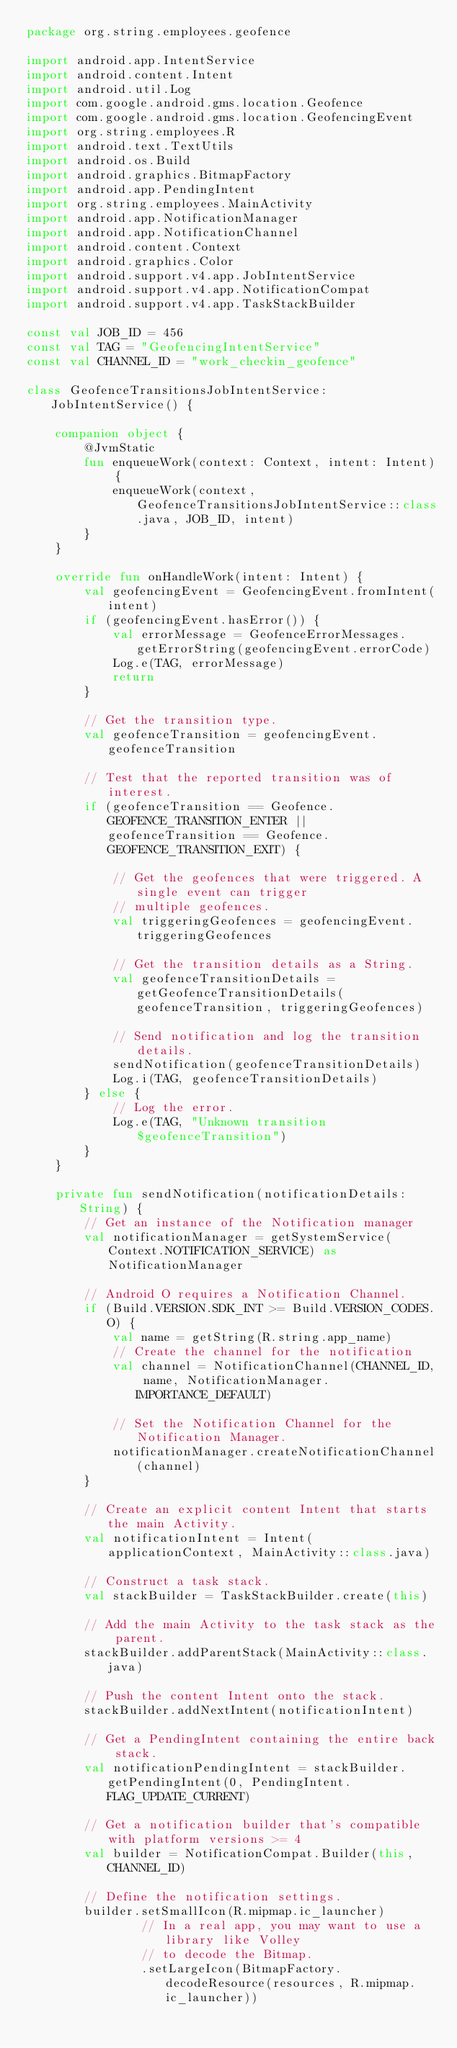<code> <loc_0><loc_0><loc_500><loc_500><_Kotlin_>package org.string.employees.geofence

import android.app.IntentService
import android.content.Intent
import android.util.Log
import com.google.android.gms.location.Geofence
import com.google.android.gms.location.GeofencingEvent
import org.string.employees.R
import android.text.TextUtils
import android.os.Build
import android.graphics.BitmapFactory
import android.app.PendingIntent
import org.string.employees.MainActivity
import android.app.NotificationManager
import android.app.NotificationChannel
import android.content.Context
import android.graphics.Color
import android.support.v4.app.JobIntentService
import android.support.v4.app.NotificationCompat
import android.support.v4.app.TaskStackBuilder

const val JOB_ID = 456
const val TAG = "GeofencingIntentService"
const val CHANNEL_ID = "work_checkin_geofence"

class GeofenceTransitionsJobIntentService: JobIntentService() {

    companion object {
        @JvmStatic
        fun enqueueWork(context: Context, intent: Intent) {
            enqueueWork(context, GeofenceTransitionsJobIntentService::class.java, JOB_ID, intent)
        }
    }

    override fun onHandleWork(intent: Intent) {
        val geofencingEvent = GeofencingEvent.fromIntent(intent)
        if (geofencingEvent.hasError()) {
            val errorMessage = GeofenceErrorMessages.getErrorString(geofencingEvent.errorCode)
            Log.e(TAG, errorMessage)
            return
        }

        // Get the transition type.
        val geofenceTransition = geofencingEvent.geofenceTransition

        // Test that the reported transition was of interest.
        if (geofenceTransition == Geofence.GEOFENCE_TRANSITION_ENTER || geofenceTransition == Geofence.GEOFENCE_TRANSITION_EXIT) {

            // Get the geofences that were triggered. A single event can trigger
            // multiple geofences.
            val triggeringGeofences = geofencingEvent.triggeringGeofences

            // Get the transition details as a String.
            val geofenceTransitionDetails = getGeofenceTransitionDetails(geofenceTransition, triggeringGeofences)

            // Send notification and log the transition details.
            sendNotification(geofenceTransitionDetails)
            Log.i(TAG, geofenceTransitionDetails)
        } else {
            // Log the error.
            Log.e(TAG, "Unknown transition $geofenceTransition")
        }
    }

    private fun sendNotification(notificationDetails: String) {
        // Get an instance of the Notification manager
        val notificationManager = getSystemService(Context.NOTIFICATION_SERVICE) as NotificationManager

        // Android O requires a Notification Channel.
        if (Build.VERSION.SDK_INT >= Build.VERSION_CODES.O) {
            val name = getString(R.string.app_name)
            // Create the channel for the notification
            val channel = NotificationChannel(CHANNEL_ID, name, NotificationManager.IMPORTANCE_DEFAULT)

            // Set the Notification Channel for the Notification Manager.
            notificationManager.createNotificationChannel(channel)
        }

        // Create an explicit content Intent that starts the main Activity.
        val notificationIntent = Intent(applicationContext, MainActivity::class.java)

        // Construct a task stack.
        val stackBuilder = TaskStackBuilder.create(this)

        // Add the main Activity to the task stack as the parent.
        stackBuilder.addParentStack(MainActivity::class.java)

        // Push the content Intent onto the stack.
        stackBuilder.addNextIntent(notificationIntent)

        // Get a PendingIntent containing the entire back stack.
        val notificationPendingIntent = stackBuilder.getPendingIntent(0, PendingIntent.FLAG_UPDATE_CURRENT)

        // Get a notification builder that's compatible with platform versions >= 4
        val builder = NotificationCompat.Builder(this, CHANNEL_ID)

        // Define the notification settings.
        builder.setSmallIcon(R.mipmap.ic_launcher)
                // In a real app, you may want to use a library like Volley
                // to decode the Bitmap.
                .setLargeIcon(BitmapFactory.decodeResource(resources, R.mipmap.ic_launcher))</code> 